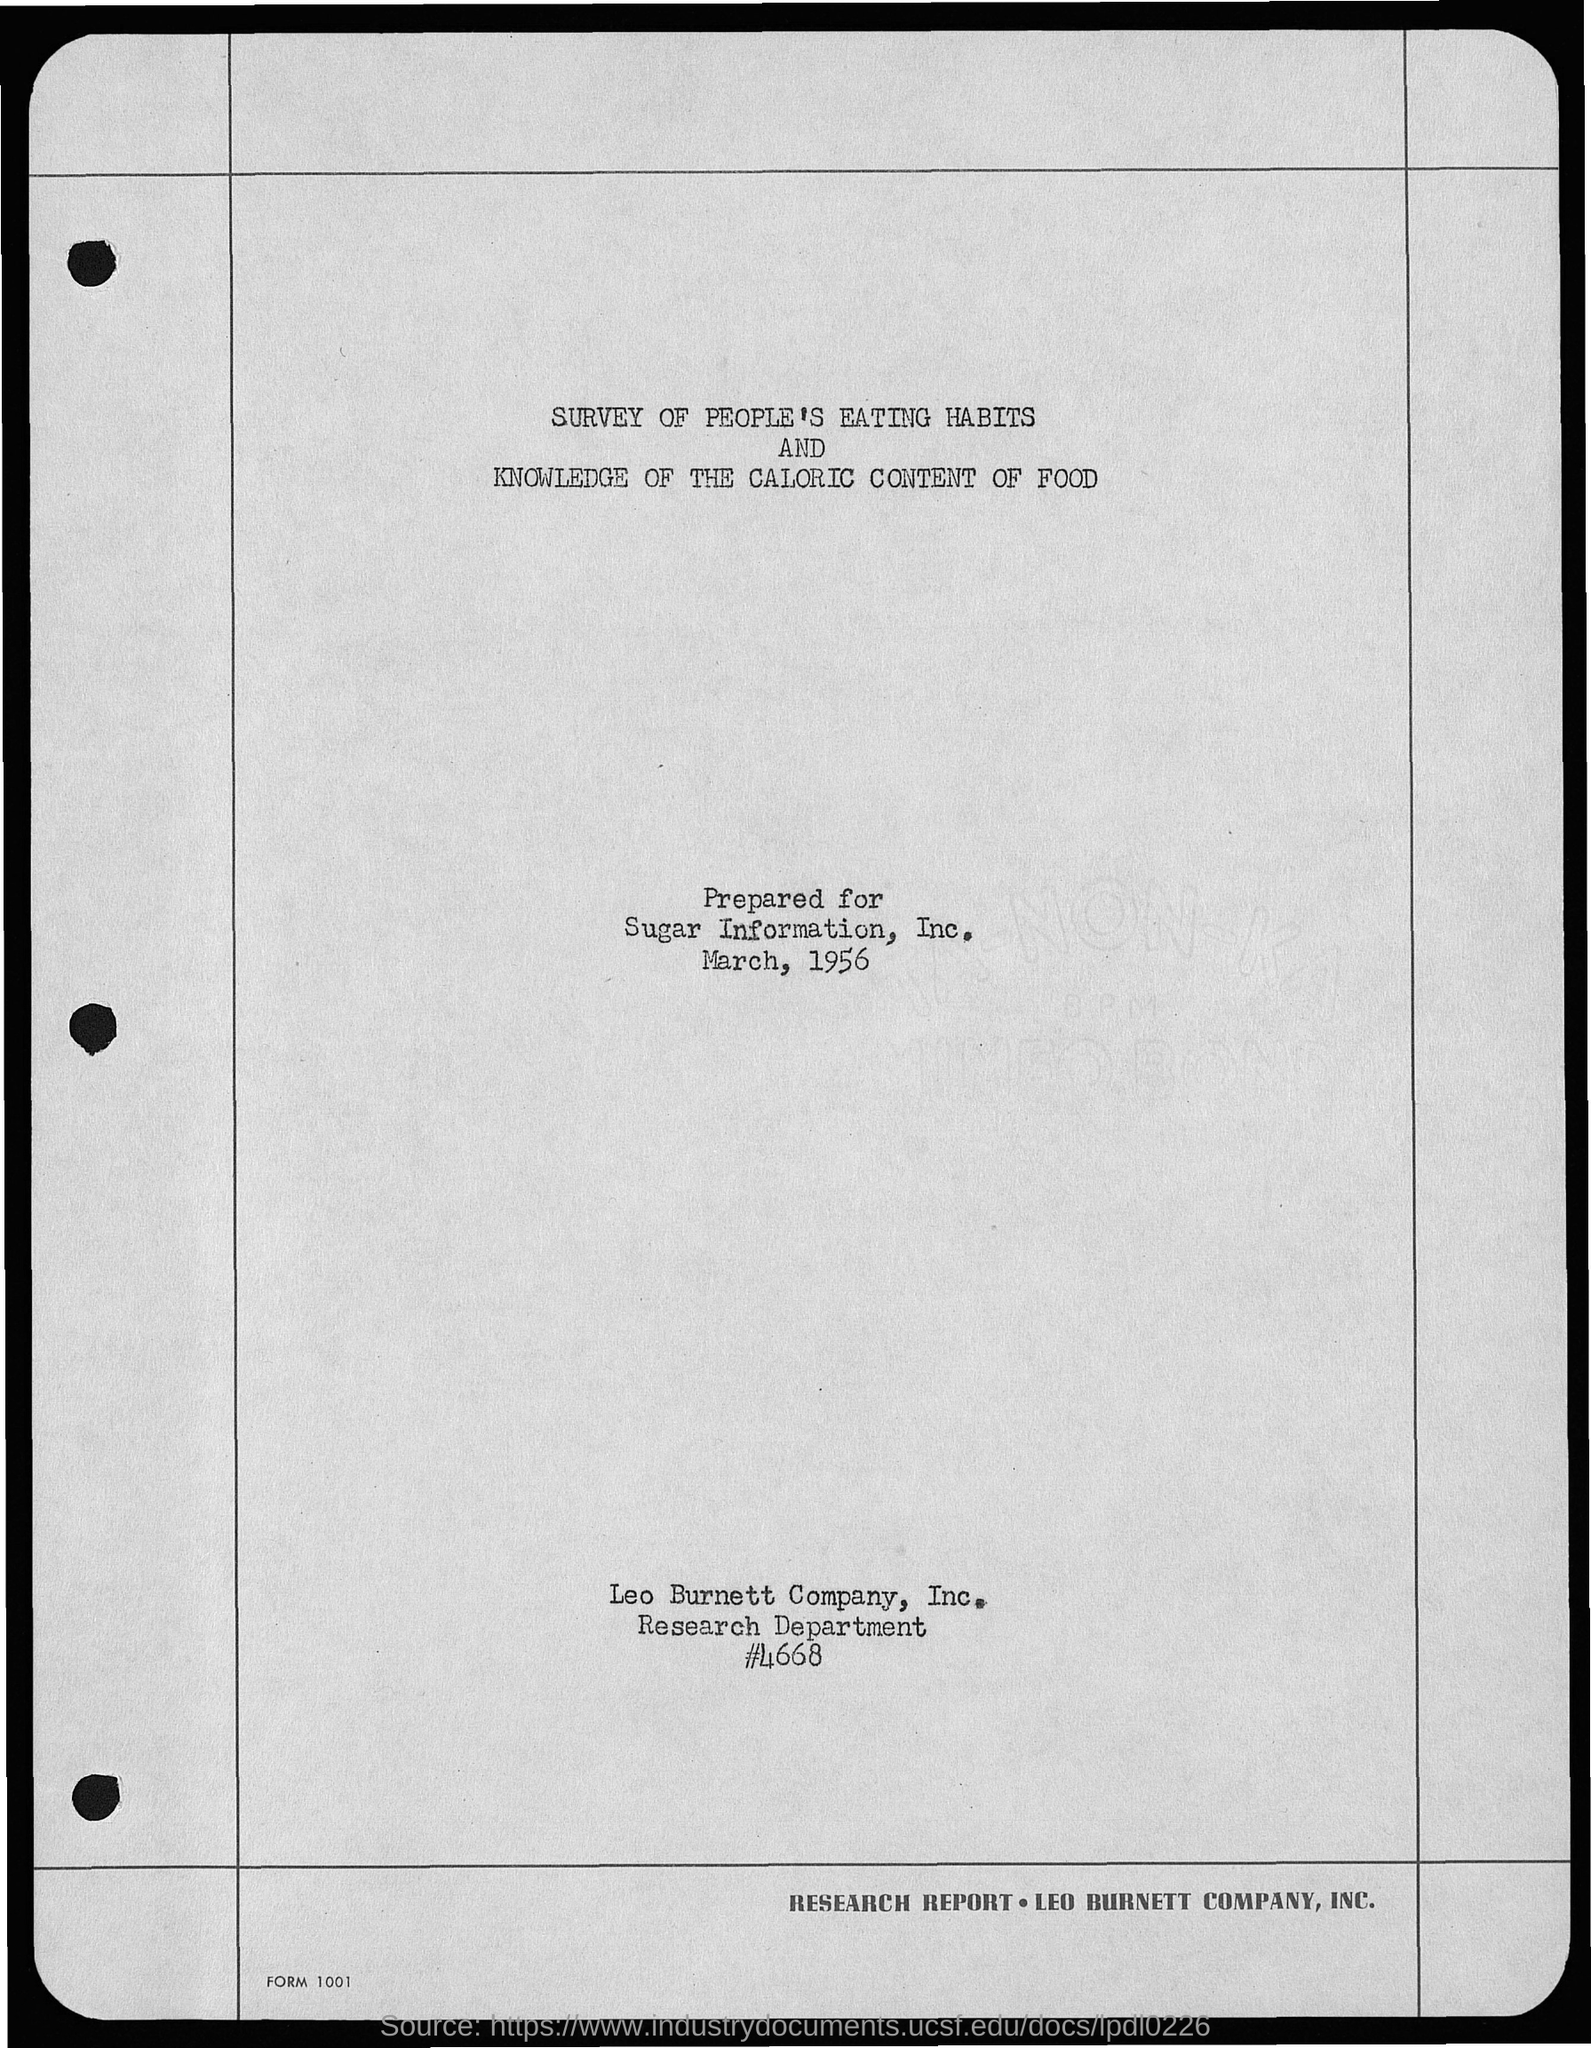Mention a couple of crucial points in this snapshot. To whom this letter was prepared, as mentioned in the given page, is Sugar Information, Inc. The year mentioned on the given page is 1956. The Research department is mentioned in the given page. March is the month mentioned in the given page. 